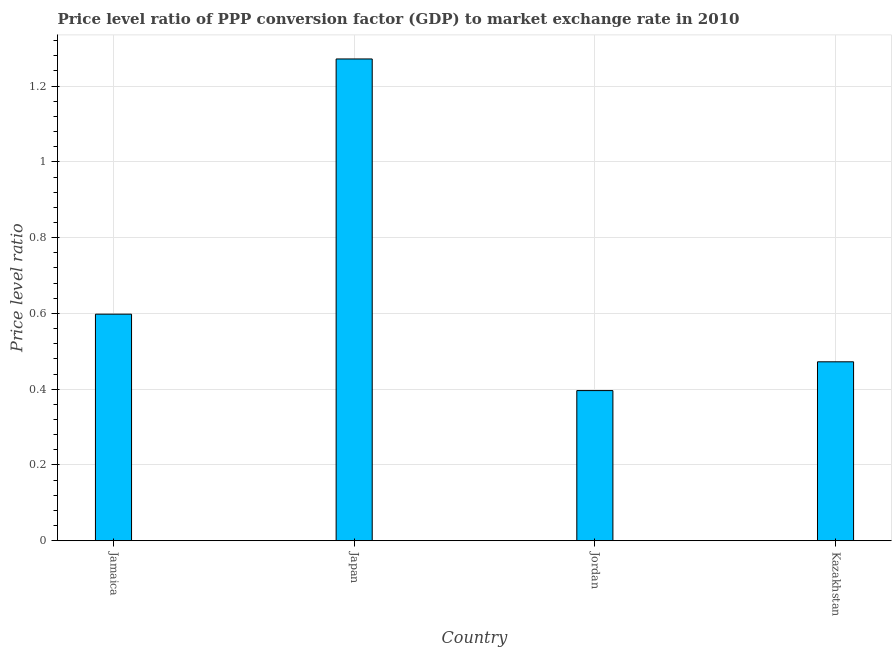Does the graph contain grids?
Give a very brief answer. Yes. What is the title of the graph?
Keep it short and to the point. Price level ratio of PPP conversion factor (GDP) to market exchange rate in 2010. What is the label or title of the Y-axis?
Your response must be concise. Price level ratio. What is the price level ratio in Jamaica?
Give a very brief answer. 0.6. Across all countries, what is the maximum price level ratio?
Provide a short and direct response. 1.27. Across all countries, what is the minimum price level ratio?
Keep it short and to the point. 0.4. In which country was the price level ratio maximum?
Your response must be concise. Japan. In which country was the price level ratio minimum?
Provide a succinct answer. Jordan. What is the sum of the price level ratio?
Your answer should be compact. 2.74. What is the difference between the price level ratio in Jordan and Kazakhstan?
Offer a terse response. -0.08. What is the average price level ratio per country?
Offer a very short reply. 0.69. What is the median price level ratio?
Provide a succinct answer. 0.54. What is the ratio of the price level ratio in Japan to that in Kazakhstan?
Your answer should be very brief. 2.69. Is the price level ratio in Jamaica less than that in Jordan?
Make the answer very short. No. What is the difference between the highest and the second highest price level ratio?
Ensure brevity in your answer.  0.67. What is the difference between the highest and the lowest price level ratio?
Keep it short and to the point. 0.88. In how many countries, is the price level ratio greater than the average price level ratio taken over all countries?
Your answer should be compact. 1. What is the Price level ratio in Jamaica?
Your response must be concise. 0.6. What is the Price level ratio in Japan?
Provide a short and direct response. 1.27. What is the Price level ratio in Jordan?
Make the answer very short. 0.4. What is the Price level ratio of Kazakhstan?
Provide a short and direct response. 0.47. What is the difference between the Price level ratio in Jamaica and Japan?
Ensure brevity in your answer.  -0.67. What is the difference between the Price level ratio in Jamaica and Jordan?
Your answer should be compact. 0.2. What is the difference between the Price level ratio in Jamaica and Kazakhstan?
Give a very brief answer. 0.13. What is the difference between the Price level ratio in Japan and Jordan?
Give a very brief answer. 0.88. What is the difference between the Price level ratio in Japan and Kazakhstan?
Your answer should be compact. 0.8. What is the difference between the Price level ratio in Jordan and Kazakhstan?
Ensure brevity in your answer.  -0.08. What is the ratio of the Price level ratio in Jamaica to that in Japan?
Your answer should be very brief. 0.47. What is the ratio of the Price level ratio in Jamaica to that in Jordan?
Your response must be concise. 1.51. What is the ratio of the Price level ratio in Jamaica to that in Kazakhstan?
Offer a very short reply. 1.27. What is the ratio of the Price level ratio in Japan to that in Jordan?
Offer a terse response. 3.21. What is the ratio of the Price level ratio in Japan to that in Kazakhstan?
Make the answer very short. 2.69. What is the ratio of the Price level ratio in Jordan to that in Kazakhstan?
Ensure brevity in your answer.  0.84. 